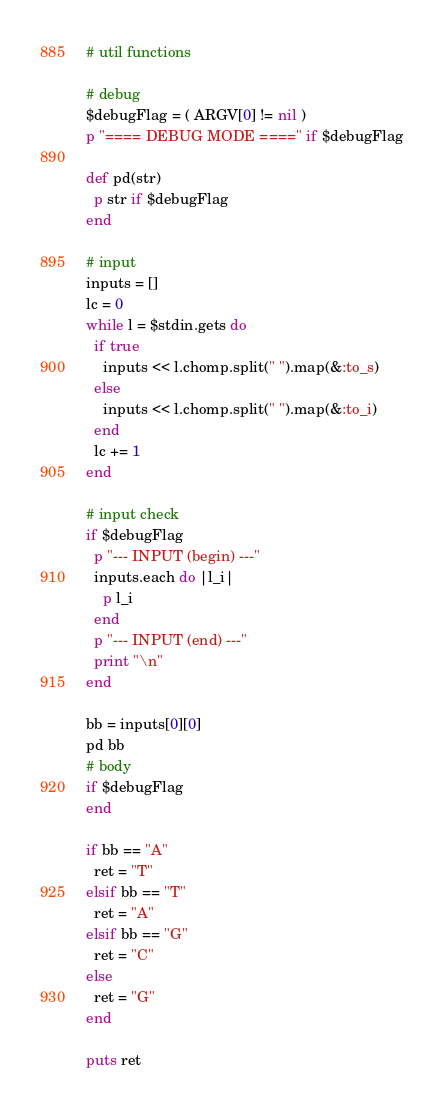<code> <loc_0><loc_0><loc_500><loc_500><_Ruby_># util functions

# debug
$debugFlag = ( ARGV[0] != nil )
p "==== DEBUG MODE ====" if $debugFlag

def pd(str)
  p str if $debugFlag
end

# input
inputs = []
lc = 0
while l = $stdin.gets do
  if true
    inputs << l.chomp.split(" ").map(&:to_s)
  else
    inputs << l.chomp.split(" ").map(&:to_i)
  end
  lc += 1
end

# input check
if $debugFlag
  p "--- INPUT (begin) ---"
  inputs.each do |l_i|
    p l_i
  end
  p "--- INPUT (end) ---"
  print "\n"
end

bb = inputs[0][0]
pd bb
# body
if $debugFlag
end

if bb == "A"
  ret = "T"
elsif bb == "T"
  ret = "A"
elsif bb == "G"
  ret = "C"
else
  ret = "G"
end

puts ret
</code> 